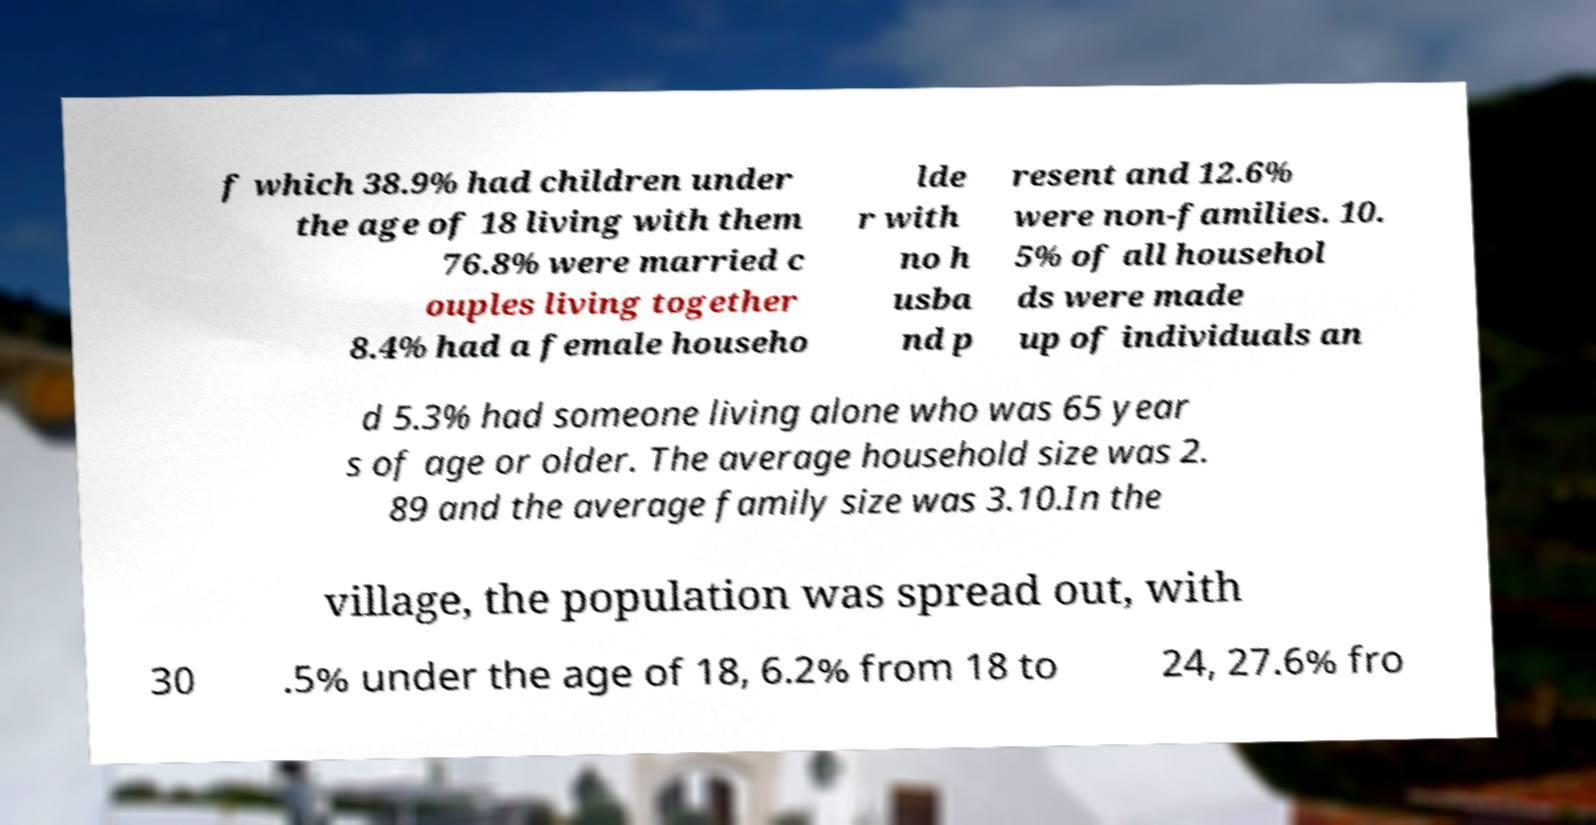Can you read and provide the text displayed in the image?This photo seems to have some interesting text. Can you extract and type it out for me? f which 38.9% had children under the age of 18 living with them 76.8% were married c ouples living together 8.4% had a female househo lde r with no h usba nd p resent and 12.6% were non-families. 10. 5% of all househol ds were made up of individuals an d 5.3% had someone living alone who was 65 year s of age or older. The average household size was 2. 89 and the average family size was 3.10.In the village, the population was spread out, with 30 .5% under the age of 18, 6.2% from 18 to 24, 27.6% fro 